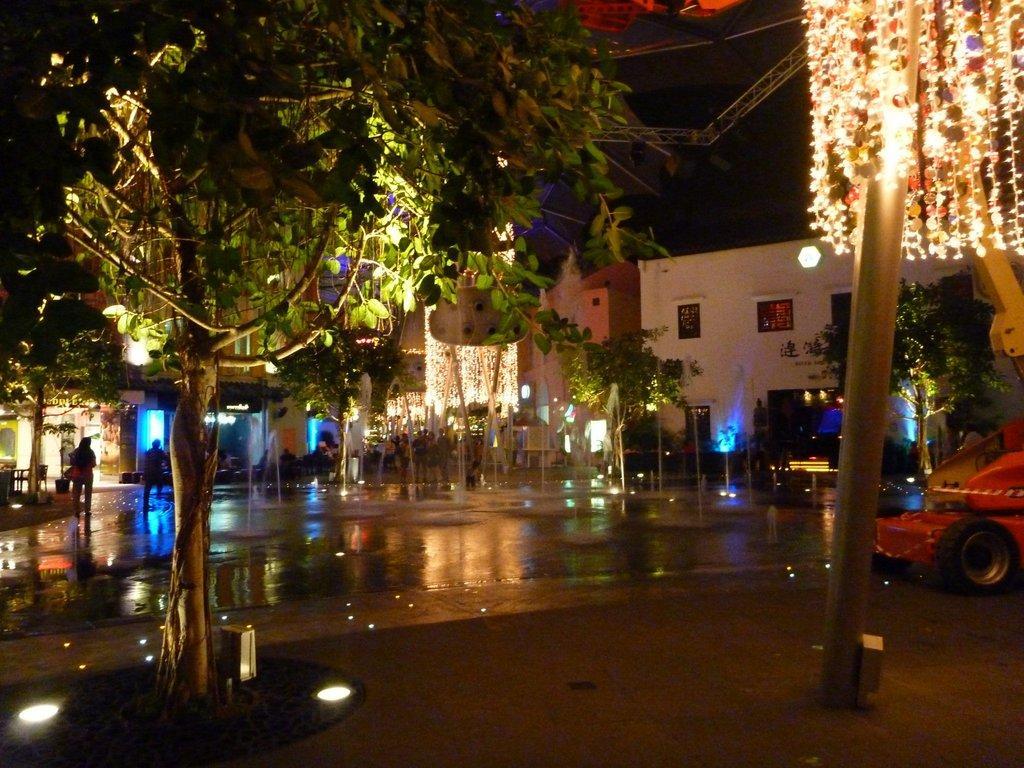How would you summarize this image in a sentence or two? In the middle of the image there are some trees and vehicles and few people are walking. Behind the trees there are some buildings. 